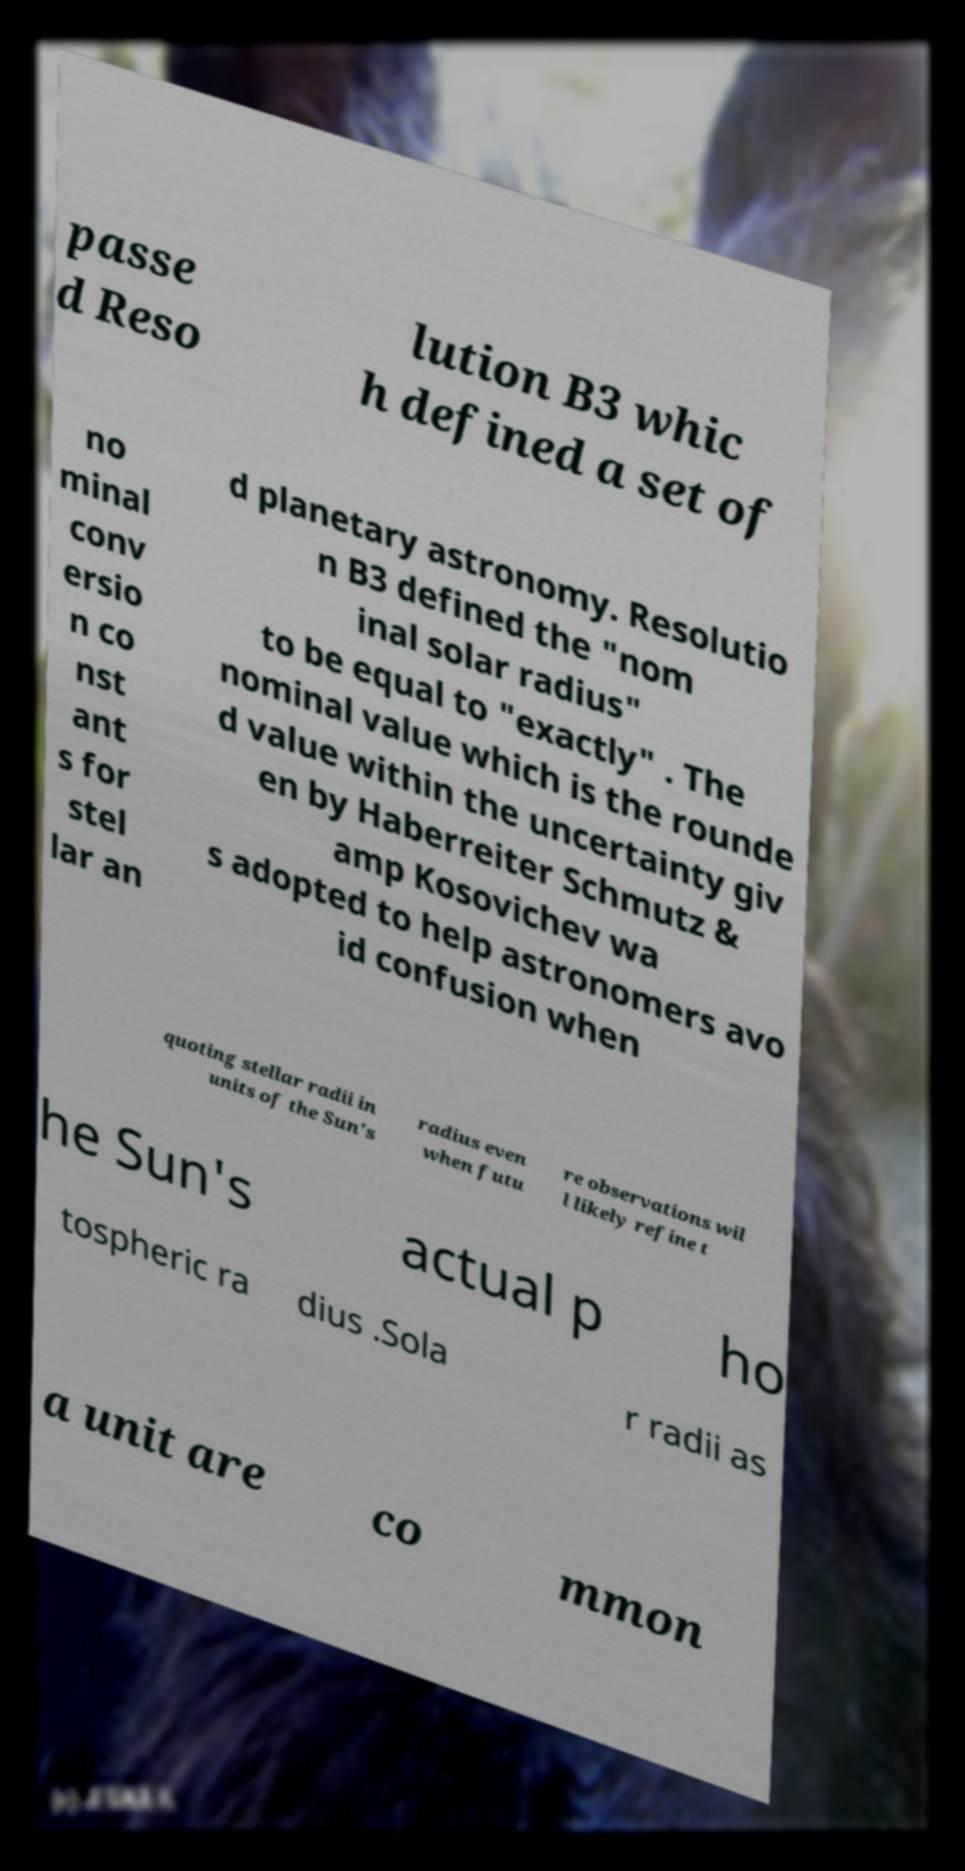Please identify and transcribe the text found in this image. passe d Reso lution B3 whic h defined a set of no minal conv ersio n co nst ant s for stel lar an d planetary astronomy. Resolutio n B3 defined the "nom inal solar radius" to be equal to "exactly" . The nominal value which is the rounde d value within the uncertainty giv en by Haberreiter Schmutz & amp Kosovichev wa s adopted to help astronomers avo id confusion when quoting stellar radii in units of the Sun's radius even when futu re observations wil l likely refine t he Sun's actual p ho tospheric ra dius .Sola r radii as a unit are co mmon 